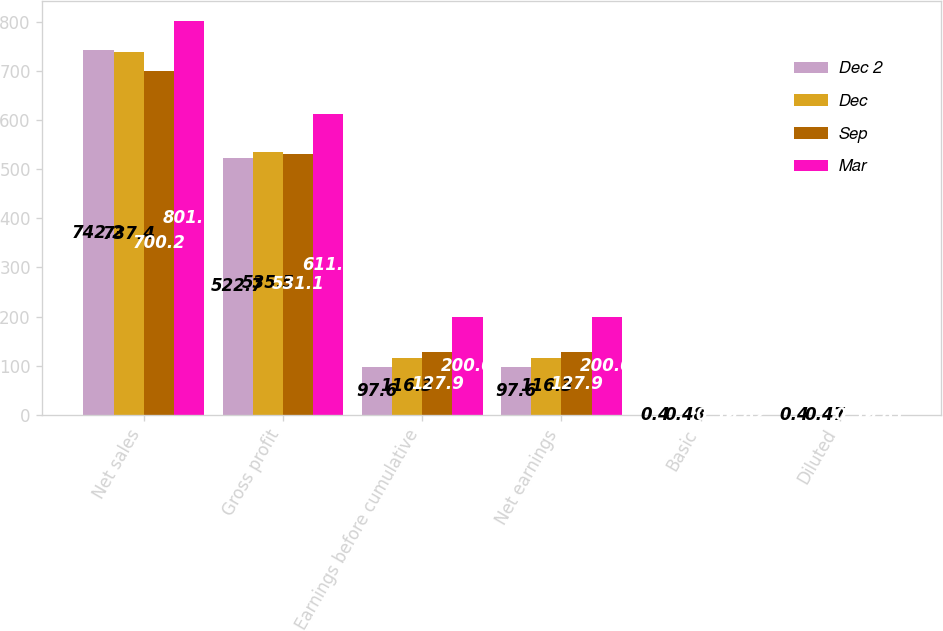<chart> <loc_0><loc_0><loc_500><loc_500><stacked_bar_chart><ecel><fcel>Net sales<fcel>Gross profit<fcel>Earnings before cumulative<fcel>Net earnings<fcel>Basic<fcel>Diluted<nl><fcel>Dec 2<fcel>742.2<fcel>522.7<fcel>97.6<fcel>97.6<fcel>0.4<fcel>0.4<nl><fcel>Dec<fcel>737.4<fcel>535.5<fcel>116.3<fcel>116.3<fcel>0.48<fcel>0.47<nl><fcel>Sep<fcel>700.2<fcel>531.1<fcel>127.9<fcel>127.9<fcel>0.52<fcel>0.52<nl><fcel>Mar<fcel>801.1<fcel>611.7<fcel>200<fcel>200<fcel>0.82<fcel>0.81<nl></chart> 